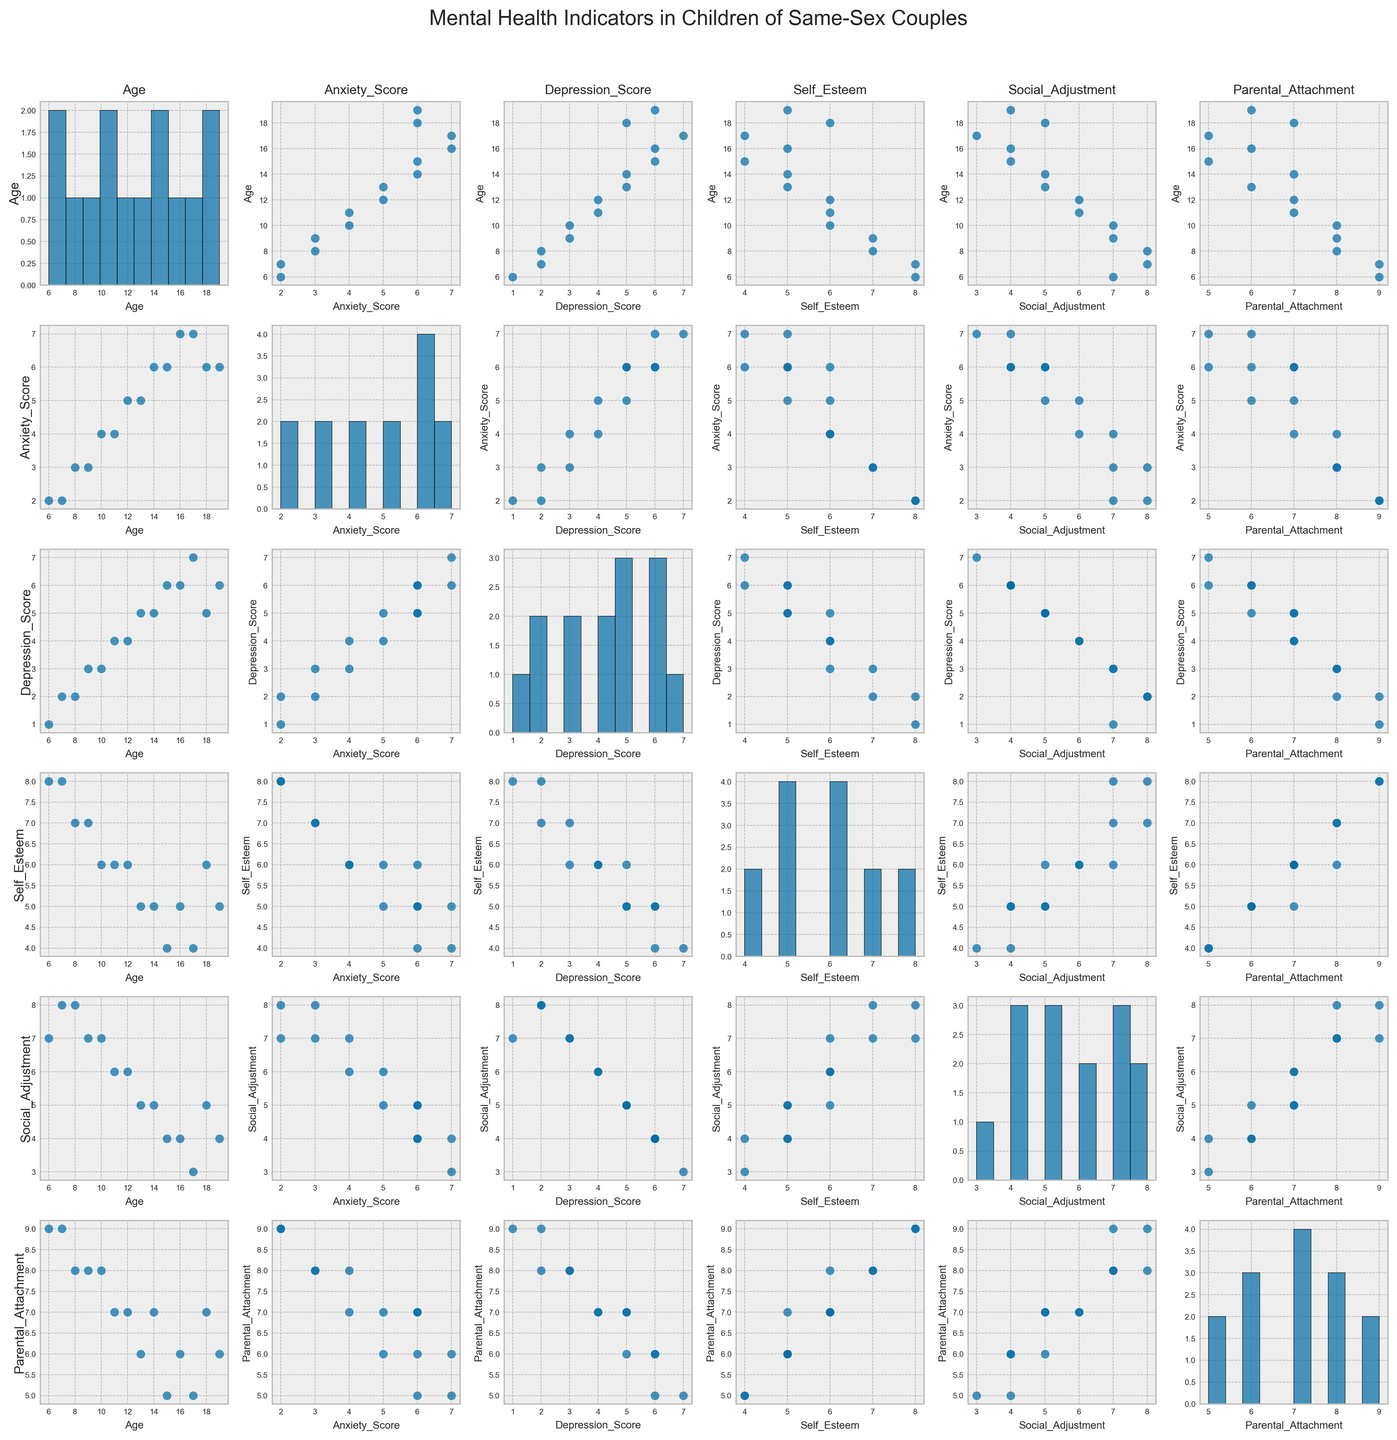What's the title of the figure? The title of the figure is typically placed at the top of the plot for easy identification. In this scatterplot matrix, the title is clearly marked at the top center of the image.
Answer: Mental Health Indicators in Children of Same-Sex Couples Which variable is plotted along the horizontal axis in the top row, second column? To identify the variable plotted along the horizontal axis, look at the top of the figure where the variable names are labeled. In the top row, second column, the horizontal axis is labeled with this variable.
Answer: Anxiety_Score What pattern do you observe between Age and Depression Score? To observe patterns between Age and Depression Score, locate the scatterplots where Age is plotted against Depression Score. Notice if there's an increasing, decreasing, or no trend in the data points distribution.
Answer: There is an increasing trend Which mental health indicator appears to have the most uniform distribution across the age span? Check the distribution histograms along the diagonal of the scatterplot matrix, where each variable's data is plotted against itself. Look for the histogram that shows the most even spread of data points across bins.
Answer: Age Is there any visible correlation between Self Esteem and Social Adjustment? Locate the scatterplot where Self Esteem is plotted against Social Adjustment. Analyze if the data points form any discernible pattern or if they are spread out with no apparent correlation.
Answer: Yes, a positive correlation Which indicator shows the greatest variability in its distribution? Examine the histograms along the diagonal to determine which indicator has the widest spread of data across its bins, indicating more variability.
Answer: Self_Esteem Are Social Adjustment and Parental Attachment positively or negatively correlated? Find the scatterplot where Social Adjustment is plotted against Parental Attachment. Check if the trend of the data points suggests that as one variable increases, the other one also increases (positive correlation), or decreases (negative correlation), or shows no clear trend.
Answer: Positively correlated Which two indicators seem to have a negative relationship? Look through the scatterplots in the matrix to identify any pair where the trend of data points shows that as one indicator increases, the other decreases. This signifies a negative relationship.
Answer: Anxiety_Score and Social_Adjustment At approximately what age do we see a significant rise in Anxiety Score? Refer to the scatterplot of Age versus Anxiety Score. Identify the age point around which the Anxiety Score starts to rise noticeably.
Answer: Around age 12 Is there a relationship between Depression Score and Parental Attachment? Locate the scatterplot that plots Depression Score against Parental Attachment and observe if there is any trend that suggests a relationship between these two variables.
Answer: No clear relationship 